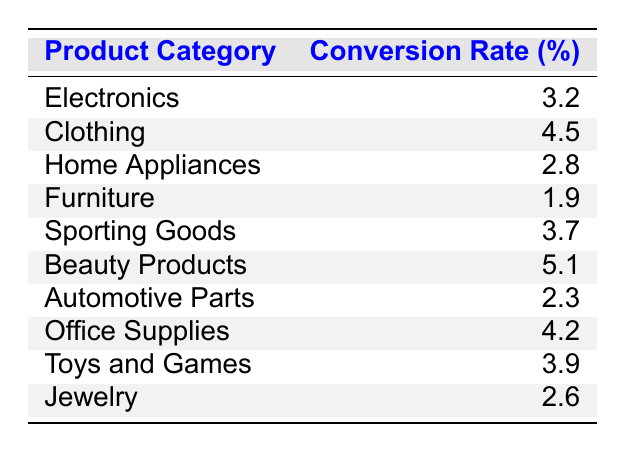What is the highest conversion rate among the product categories? From the table, we can look for the product category with the highest percentage in the conversion rate column. The conversion rates are: Electronics (3.2), Clothing (4.5), Home Appliances (2.8), Furniture (1.9), Sporting Goods (3.7), Beauty Products (5.1), Automotive Parts (2.3), Office Supplies (4.2), Toys and Games (3.9), Jewelry (2.6). The highest value is 5.1 for Beauty Products.
Answer: 5.1 Which product category has the lowest conversion rate? By examining the conversion rates in the table, we look for the lowest percentage listed. The conversion rates include values ranging from 1.9 to 5.1, with Furniture having the lowest value of 1.9.
Answer: 1.9 What is the average conversion rate of Sporting Goods and Office Supplies? To calculate the average, first, we find the conversion rates for each: Sporting Goods is 3.7 and Office Supplies is 4.2. Next, we add these values: 3.7 + 4.2 = 7.9. Finally, divide by 2 (the number of categories) to find the average: 7.9 / 2 = 3.95.
Answer: 3.95 Is the conversion rate for Beauty Products greater than 4%? The conversion rate for Beauty Products is 5.1, which is greater than 4%. Therefore, the statement is true.
Answer: Yes What is the difference between the conversion rates of Clothing and Automotive Parts? The conversion rate for Clothing is 4.5 and for Automotive Parts, it is 2.3. To find the difference, we subtract: 4.5 - 2.3 = 2.2. This indicates that Clothing has a higher conversion rate by 2.2 percentage points.
Answer: 2.2 Are there any product categories with a conversion rate less than 3%? The conversion rates for all the categories are compared, and we find that Furniture (1.9), Home Appliances (2.8), and Automotive Parts (2.3) all have conversion rates below 3%. This confirms that there are categories with conversion rates less than 3%.
Answer: Yes What is the total conversion rate of all product categories? To find the total conversion rate, we sum all the individual conversion rates: 3.2 + 4.5 + 2.8 + 1.9 + 3.7 + 5.1 + 2.3 + 4.2 + 3.9 + 2.6 = 34.2. The total conversion rate across all the categories is therefore 34.2.
Answer: 34.2 How many product categories have a conversion rate of 3.5% or higher? We list the product categories meeting this condition: Clothing (4.5), Sporting Goods (3.7), Beauty Products (5.1), Office Supplies (4.2), Toys and Games (3.9). In total, there are 5 product categories with conversion rates of 3.5% or higher.
Answer: 5 Which category would you prioritize for sales strategies based on the conversion rates? Based on the conversion rates in the table, Beauty Products (5.1) has the highest conversion rate, making it the priority for sales strategies as it indicates strong customer interest and potential for revenue.
Answer: Beauty Products 